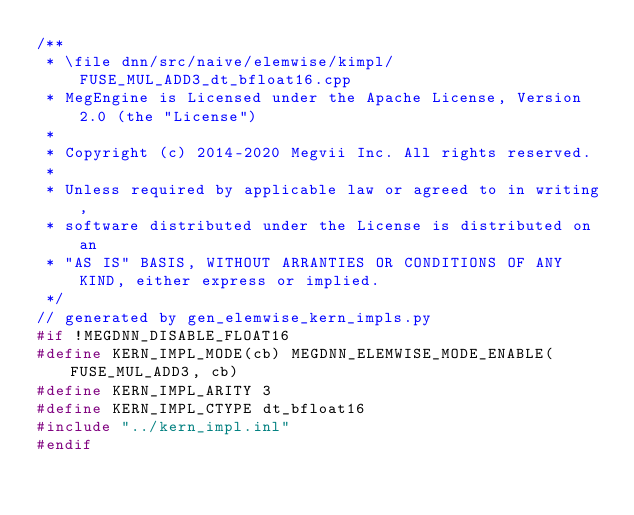Convert code to text. <code><loc_0><loc_0><loc_500><loc_500><_C++_>/**
 * \file dnn/src/naive/elemwise/kimpl/FUSE_MUL_ADD3_dt_bfloat16.cpp
 * MegEngine is Licensed under the Apache License, Version 2.0 (the "License")
 *
 * Copyright (c) 2014-2020 Megvii Inc. All rights reserved.
 *
 * Unless required by applicable law or agreed to in writing,
 * software distributed under the License is distributed on an
 * "AS IS" BASIS, WITHOUT ARRANTIES OR CONDITIONS OF ANY KIND, either express or implied.
 */
// generated by gen_elemwise_kern_impls.py
#if !MEGDNN_DISABLE_FLOAT16
#define KERN_IMPL_MODE(cb) MEGDNN_ELEMWISE_MODE_ENABLE(FUSE_MUL_ADD3, cb)
#define KERN_IMPL_ARITY 3
#define KERN_IMPL_CTYPE dt_bfloat16
#include "../kern_impl.inl"
#endif
</code> 